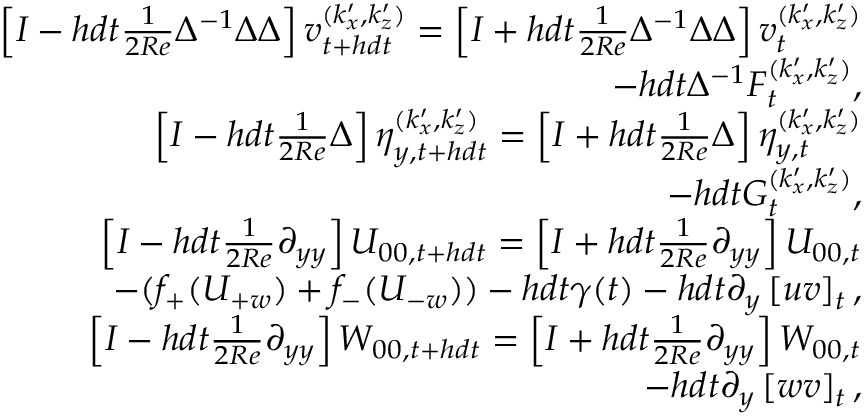Convert formula to latex. <formula><loc_0><loc_0><loc_500><loc_500>\begin{array} { r } { \left [ I - h d t \frac { 1 } { 2 R e } \Delta ^ { - 1 } \Delta \Delta \right ] v _ { t + h d t } ^ { ( k _ { x } ^ { \prime } , k _ { z } ^ { \prime } ) } = \left [ I + h d t \frac { 1 } { 2 R e } \Delta ^ { - 1 } \Delta \Delta \right ] v _ { t } ^ { ( k _ { x } ^ { \prime } , k _ { z } ^ { \prime } ) } } \\ { - h d t \Delta ^ { - 1 } F _ { t } ^ { ( k _ { x } ^ { \prime } , k _ { z } ^ { \prime } ) } , } \\ { \left [ I - h d t \frac { 1 } { 2 R e } \Delta \right ] \eta _ { y , t + h d t } ^ { ( k _ { x } ^ { \prime } , k _ { z } ^ { \prime } ) } = \left [ I + h d t \frac { 1 } { 2 R e } \Delta \right ] \eta _ { y , t } ^ { ( k _ { x } ^ { \prime } , k _ { z } ^ { \prime } ) } } \\ { - h d t G _ { t } ^ { ( k _ { x } ^ { \prime } , k _ { z } ^ { \prime } ) } , } \\ { \left [ I - h d t \frac { 1 } { 2 R e } \partial _ { y y } \right ] U _ { 0 0 , t + h d t } = \left [ I + h d t \frac { 1 } { 2 R e } \partial _ { y y } \right ] U _ { 0 0 , t } } \\ { - ( f _ { + } ( U _ { + w } ) + f _ { - } ( U _ { - w } ) ) - h d t \gamma ( t ) - h d t \partial _ { y } \left [ u v \right ] _ { t } , } \\ { \left [ I - h d t \frac { 1 } { 2 R e } \partial _ { y y } \right ] W _ { 0 0 , t + h d t } = \left [ I + h d t \frac { 1 } { 2 R e } \partial _ { y y } \right ] W _ { 0 0 , t } } \\ { - h d t \partial _ { y } \left [ w v \right ] _ { t } , } \end{array}</formula> 